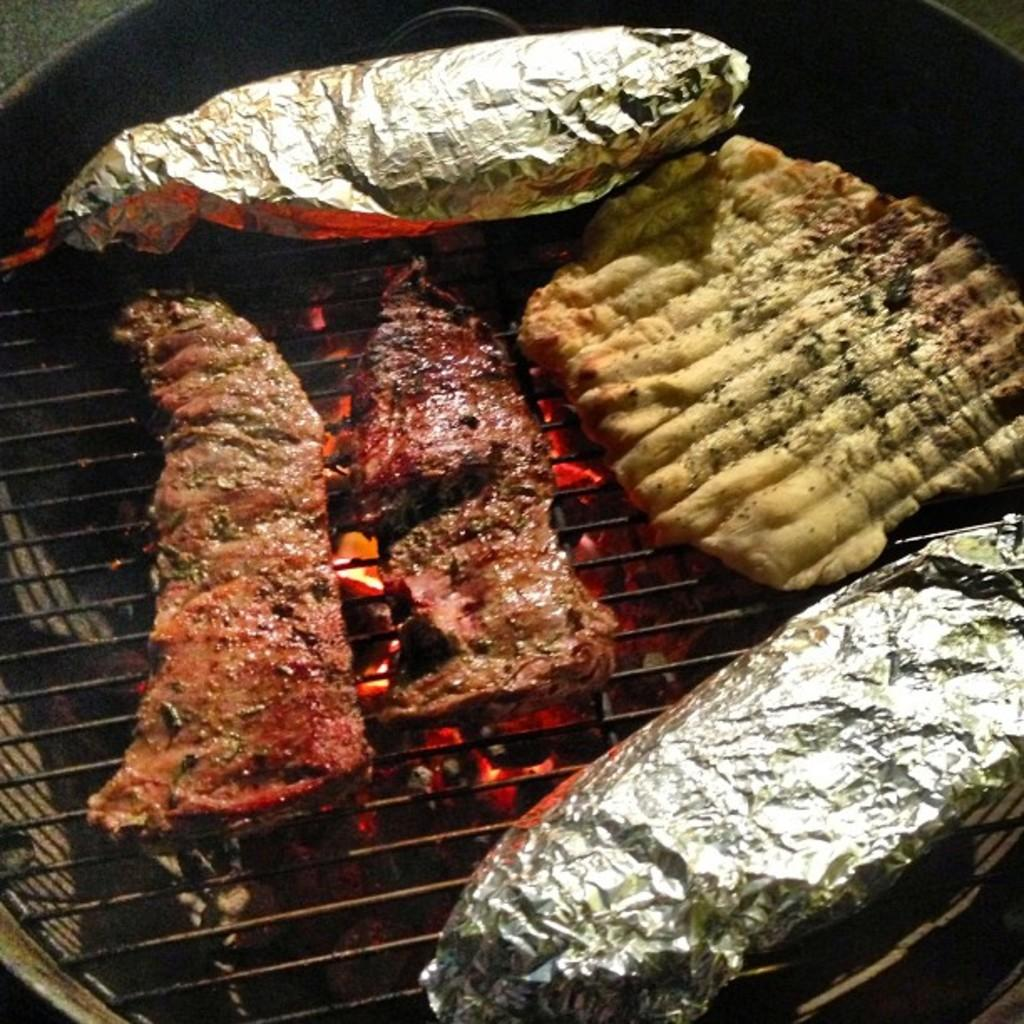What type of objects can be seen in the image? There are food items in the image. What is the material of the foil placed on the grill? The foil placed on the grill is made of aluminum. What is the source of heat for cooking the food items? There is fire under the grill. What type of dog is sitting next to the grill in the image? There is no dog present in the image. Can you describe the feather pattern on the food items in the image? There are no feathers present on the food items in the image. 